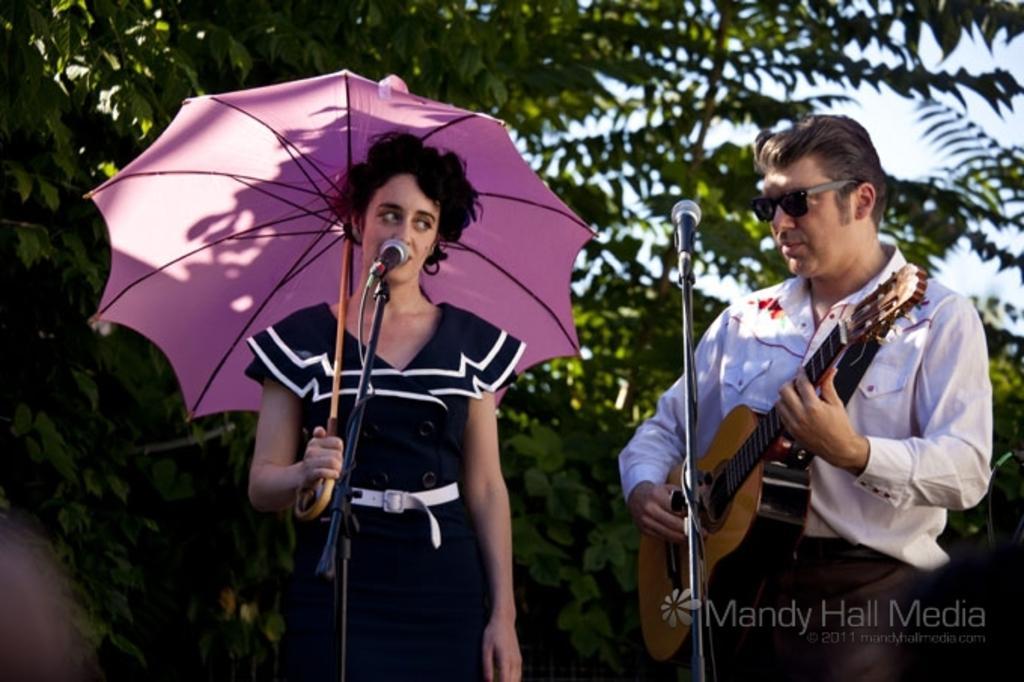Describe this image in one or two sentences. In this picture two people are standing among them one is a woman who is holding the umbrella and the other is a man who is holding the guitar. 